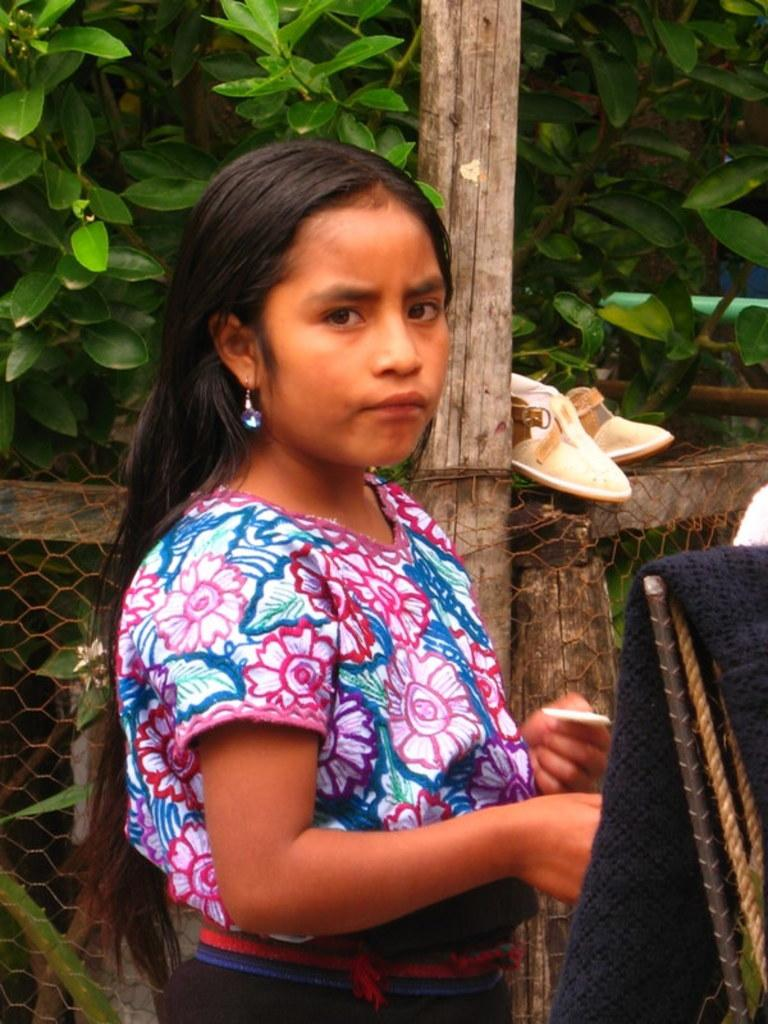Who is in the image? There is a woman in the image. What can be seen in the background of the image? There is a fence in the image. What type of vegetation is present in the image? Plants are present in the image. What type of butter is being used by the woman in the image? There is no butter present in the image, and the woman's actions are not described. --- Facts: 1. There is a car in the image. 2. The car is red. 3. The car has four wheels. 4. There is a road in the image. 5. The road is paved. Absurd Topics: parrot, sand, dance Conversation: What is the main subject of the image? The main subject of the image is a car. What color is the car? The car is red. How many wheels does the car have? The car has four wheels. What type of surface is the car on? There is a road in the image, and it is paved. Reasoning: Let's think step by step in order to produce the conversation. We start by identifying the main subject in the image, which is the car. Then, we expand the conversation to include other details about the car, such as its color and the number of wheels. Finally, we describe the setting in which the car is located, which is a paved road. Each question is designed to elicit a specific detail about the image that is known from the provided facts. Absurd Question/Answer: Can you see a parrot dancing on the sand in the image? There is no parrot or sand present in the image; it features a red car on a paved road. 